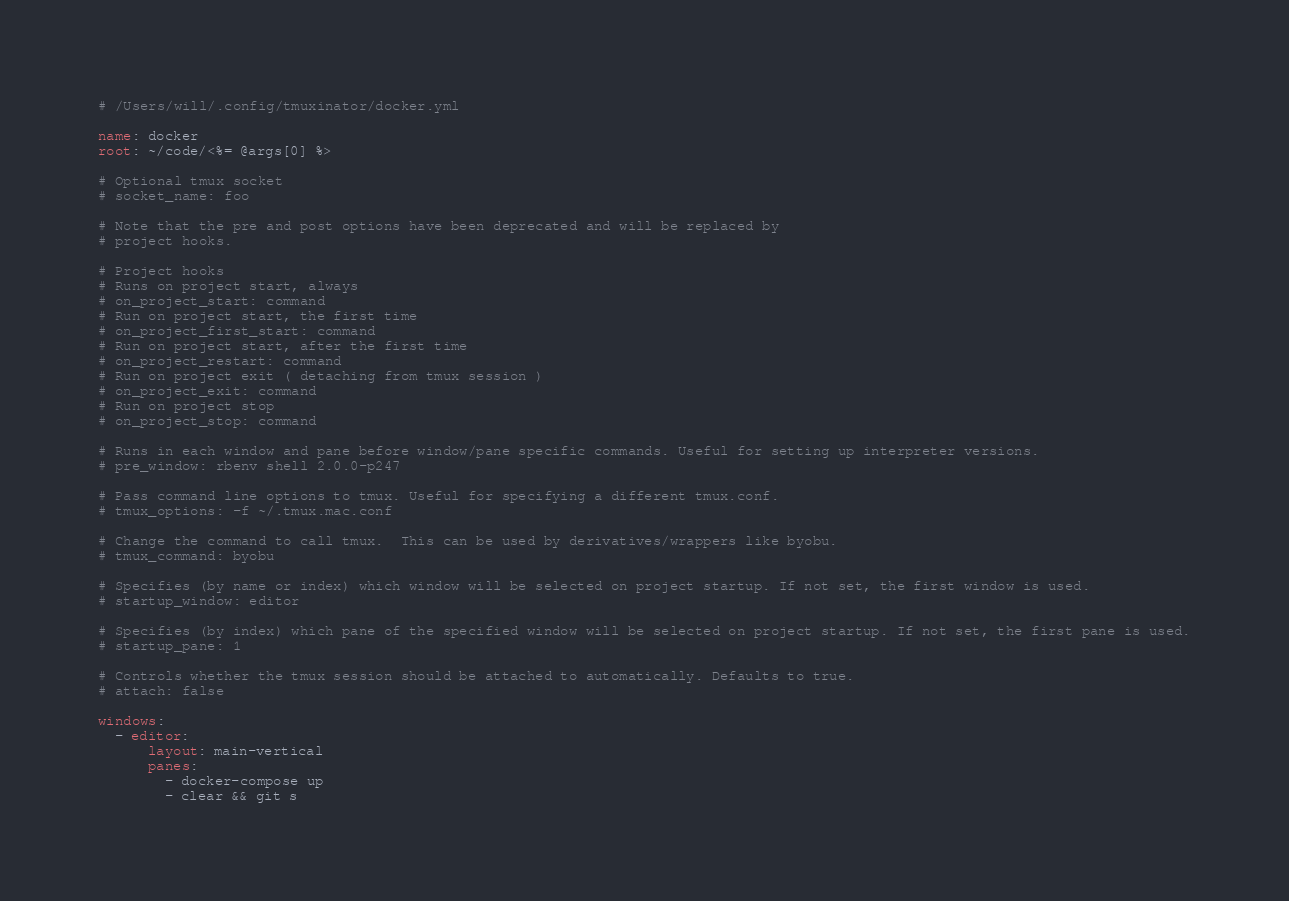Convert code to text. <code><loc_0><loc_0><loc_500><loc_500><_YAML_># /Users/will/.config/tmuxinator/docker.yml

name: docker
root: ~/code/<%= @args[0] %>

# Optional tmux socket
# socket_name: foo

# Note that the pre and post options have been deprecated and will be replaced by
# project hooks.

# Project hooks
# Runs on project start, always
# on_project_start: command
# Run on project start, the first time
# on_project_first_start: command
# Run on project start, after the first time
# on_project_restart: command
# Run on project exit ( detaching from tmux session )
# on_project_exit: command
# Run on project stop
# on_project_stop: command

# Runs in each window and pane before window/pane specific commands. Useful for setting up interpreter versions.
# pre_window: rbenv shell 2.0.0-p247

# Pass command line options to tmux. Useful for specifying a different tmux.conf.
# tmux_options: -f ~/.tmux.mac.conf

# Change the command to call tmux.  This can be used by derivatives/wrappers like byobu.
# tmux_command: byobu

# Specifies (by name or index) which window will be selected on project startup. If not set, the first window is used.
# startup_window: editor

# Specifies (by index) which pane of the specified window will be selected on project startup. If not set, the first pane is used.
# startup_pane: 1

# Controls whether the tmux session should be attached to automatically. Defaults to true.
# attach: false

windows:
  - editor:
      layout: main-vertical
      panes:
        - docker-compose up
        - clear && git s
</code> 